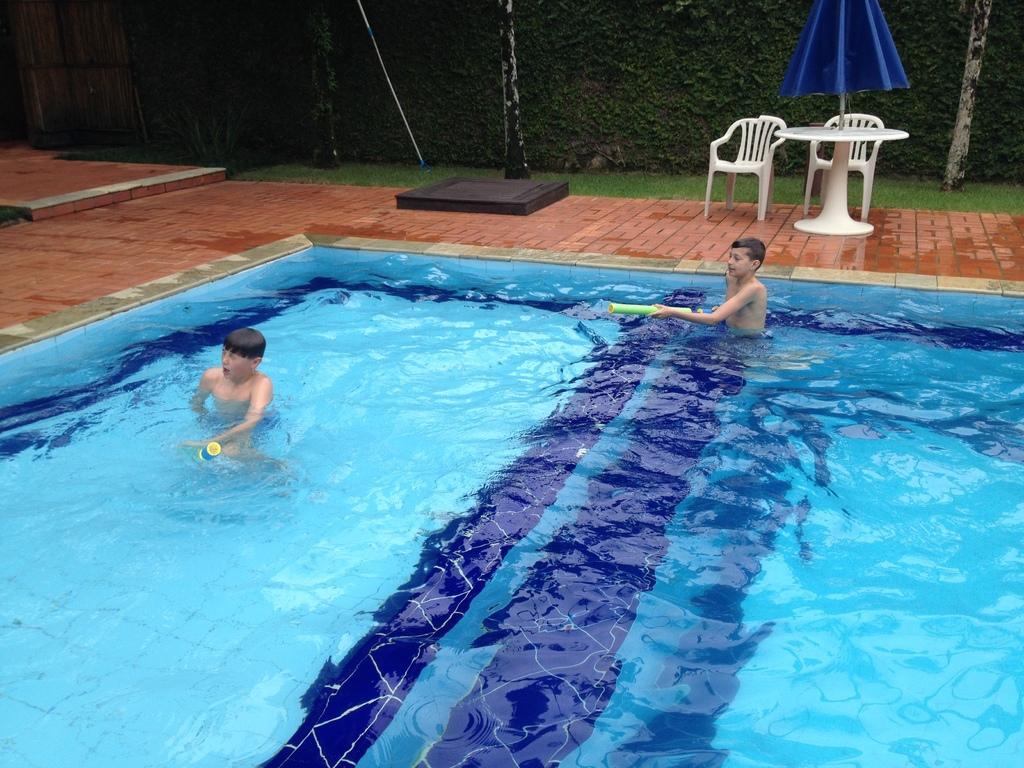Can you describe this image briefly? The picture is clicked near a pool , here we observe two kids playing in a blue color pool. In the background we can see two chairs and a blue umbrella. There is so much vegetation in the background. 